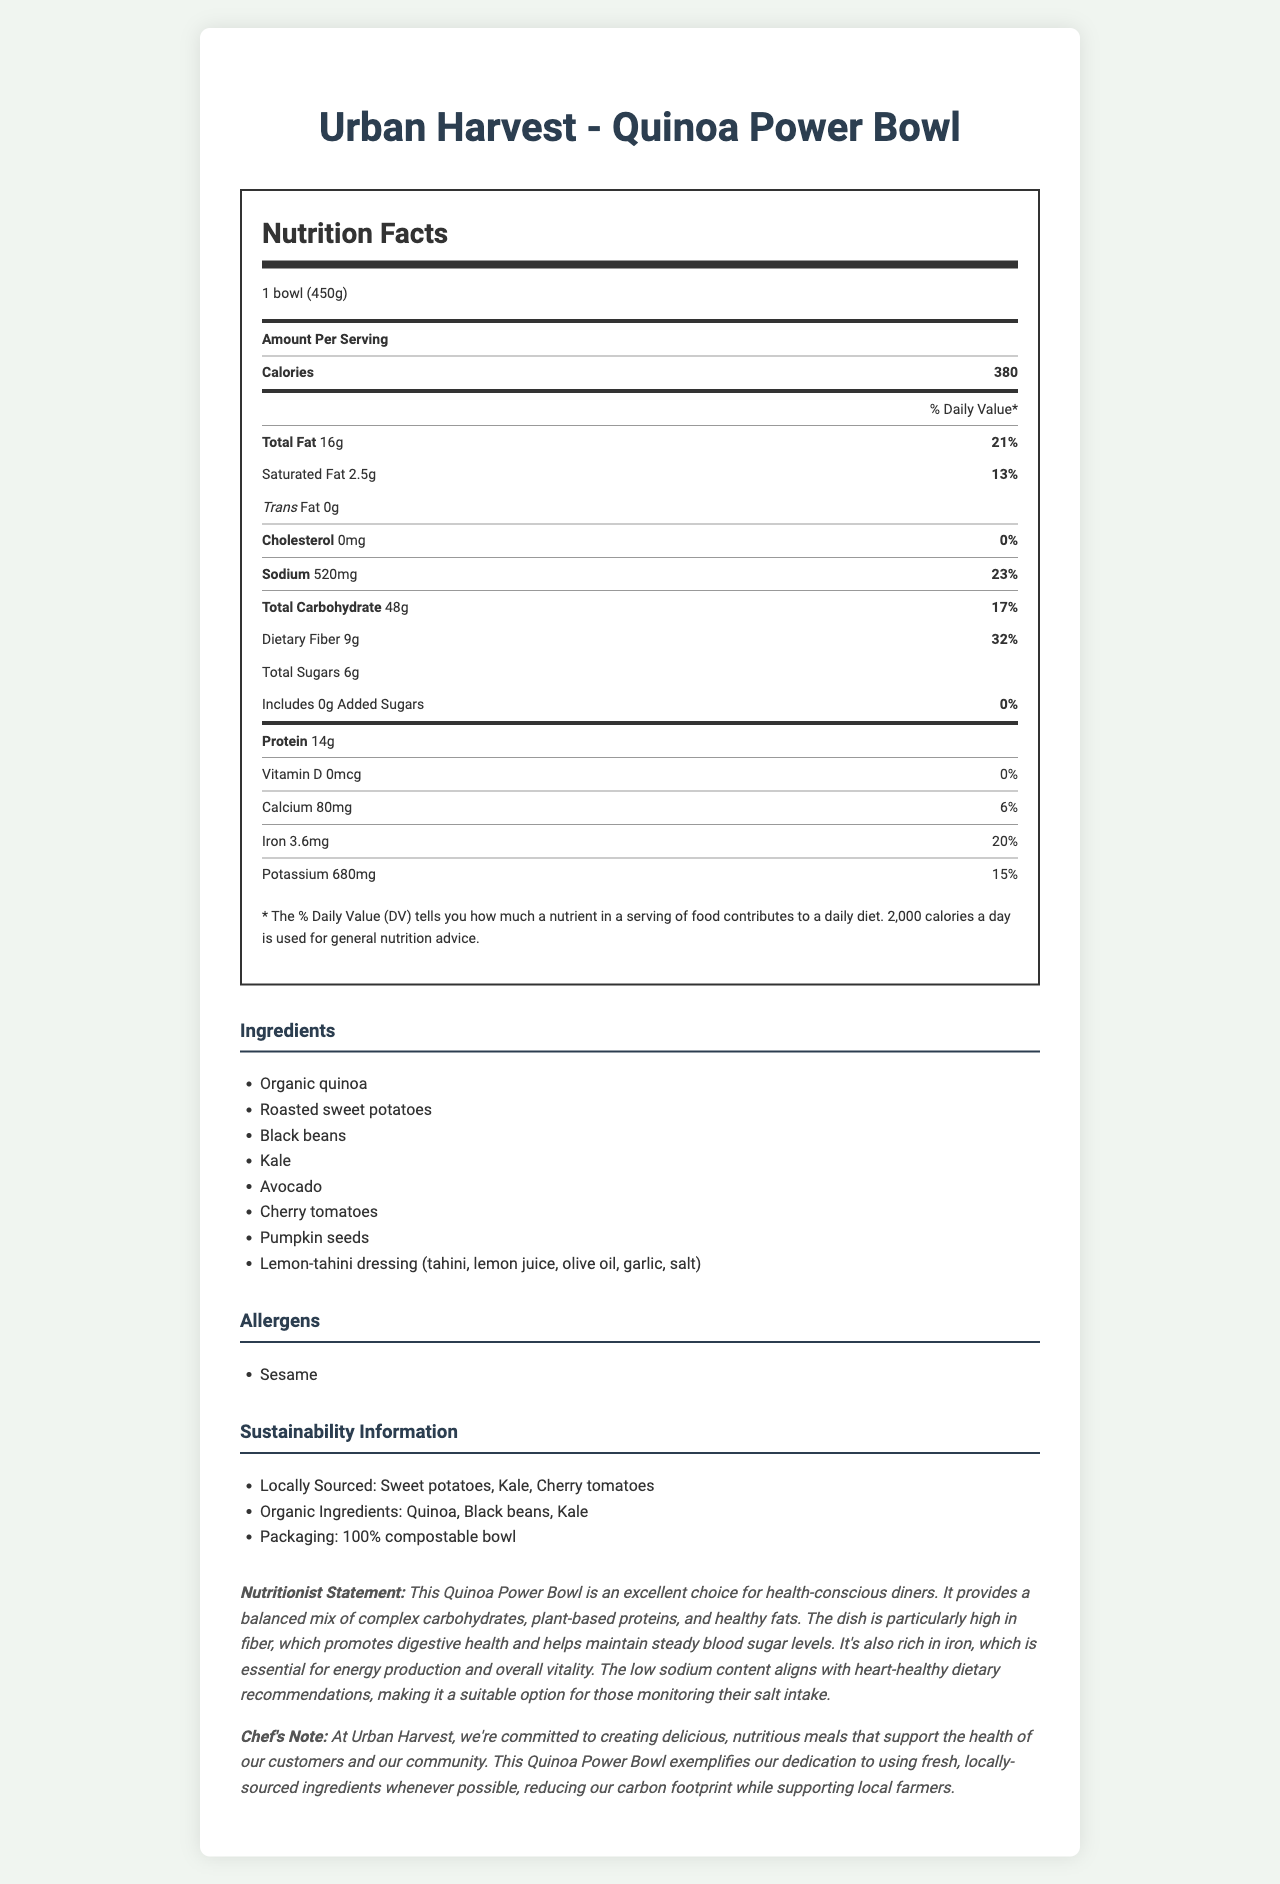what is the serving size for the Quinoa Power Bowl? The serving size is listed at the top of the Nutrition Facts section as "1 bowl (450g)".
Answer: 1 bowl (450g) how many calories are in one serving of the Quinoa Power Bowl? The calories per serving are listed prominently in the Nutrition Facts section as 380.
Answer: 380 what percentage of the daily value does the total fat represent? The total fat content is listed as 16g, which corresponds to 21% of the daily value.
Answer: 21% which ingredient in the Quinoa Power Bowl could cause allergies? The allergens section lists sesame as a potential allergen.
Answer: Sesame how much dietary fiber does the Quinoa Power Bowl contain? The amount of dietary fiber is listed as 9g.
Answer: 9g what is the sodium content in the Quinoa Power Bowl? The sodium content is listed in the Nutrition Facts section as 520mg.
Answer: 520mg what is the main source of protein in the Quinoa Power Bowl? A. Chicken B. Black beans C. Tofu The ingredients list includes black beans, which are known to be a good source of plant-based protein.
Answer: B which of the following is NOT an organic ingredient in the Quinoa Power Bowl? A. Sweet potatoes B. Quinoa C. Kale D. Black beans Sweet potatoes are listed as locally sourced but not as organic, unlike quinoa, kale, and black beans.
Answer: A is the Quinoa Power Bowl high in added sugars? The added sugars amount is 0g, which indicates there are no added sugars.
Answer: No does the Quinoa Power Bowl include any cholesterol? The document states that the cholesterol amount is 0mg, so there is no cholesterol in the dish.
Answer: No how does the outdoor seating affect Urban Harvest? The city planning considerations state that there is a permit approved for 6 outdoor tables, enhancing the restaurant's appeal especially in pandemic times.
Answer: Permit approved for 6 tables summarize the main idea of the Nutrition Facts Label for the Quinoa Power Bowl from Urban Harvest. This summarizes the main nutritional content, sustainability efforts, and city planning considerations associated with Urban Harvest's Quinoa Power Bowl.
Answer: The Quinoa Power Bowl from Urban Harvest is a health-conscious meal with a balanced mix of nutrients. It contains 380 calories per serving, with notable amounts of dietary fiber and protein, and minimal saturated fat and sodium. The ingredients include organic and locally-sourced items, and the dish is served in 100% compostable packaging. The restaurant has been designed with urban planning considerations, such as high pedestrian accessibility and proximity to public transit in mind. what feedback does the nutritionist provide about the Quinoa Power Bowl? The nutritionist describes the dish as an excellent choice for health-conscious diners due to its balanced nutrients, high fiber content, and low sodium level.
Answer: An excellent choice for health-conscious diners, promoting digestive health, and heart-healthy dietary recommendations. why did the chef choose to use locally-sourced ingredients? The chef's note mentions a commitment to using fresh, locally-sourced ingredients to reduce environmental impact and support local farmers.
Answer: To reduce the carbon footprint and support local farmers. what vitamins and minerals are present in the Quinoa Power Bowl, and in what amounts? These values are listed in the Nutrition Facts section under vitamins and minerals.
Answer: Vitamin D: 0mcg, Calcium: 80mg, Iron: 3.6mg, Potassium: 680mg how far is Urban Harvest from the main transit hub? The city planning considerations state that Urban Harvest is located within 2 blocks of the main transit hub.
Answer: Within 2 blocks what are some of the key sustainability features of Urban Harvest? The sustainability information section highlights these three key features.
Answer: Locally sourced ingredients, organic ingredients, 100% compostable packaging what certifications does Urban Harvest have for its sustainability efforts? The document does not provide any information about specific sustainability certifications.
Answer: Not enough information 